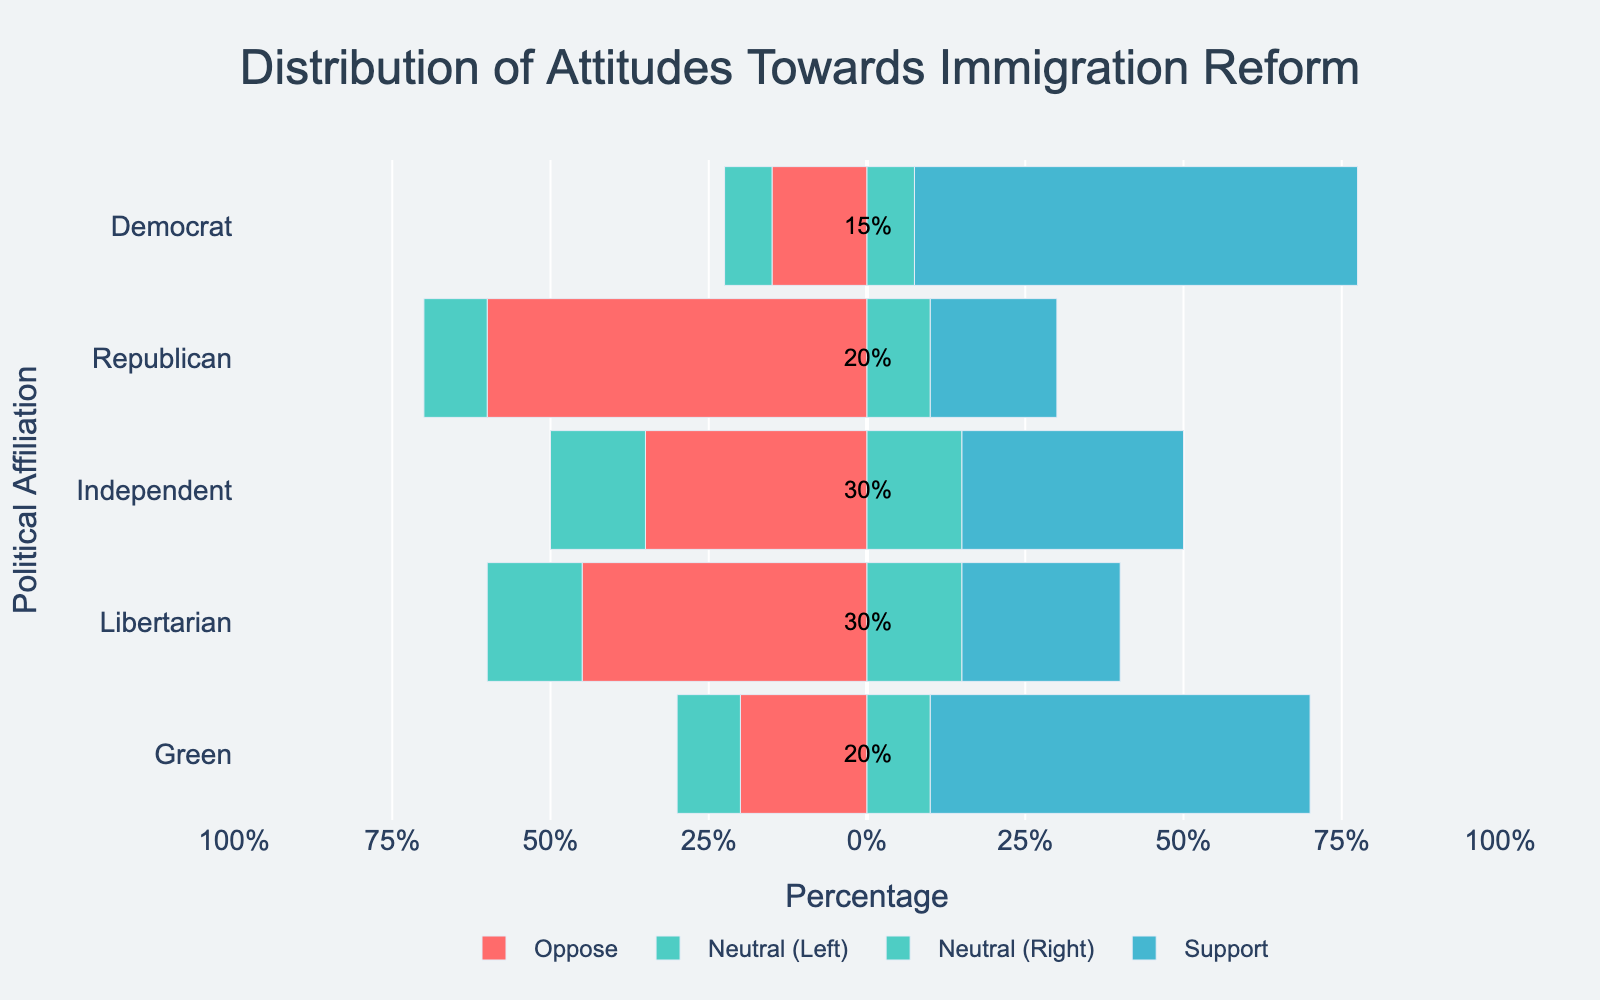what percentage of Democrats are neutral towards immigration reform? Democrats are represented by the bar for the "Democrat" category. The neutral segment is highlighted in green, with an annotation of 15%.
Answer: 15% which political affiliation has the highest percentage of strong support for immigration reform? By examining the bar segments coded in blue (strong support) for each political affiliation, the Democrat category has the highest percentage, indicated by the large blue section.
Answer: Democrats how does the opposition to immigration reform among Republicans compare to Libertarians? Both bars (Republican and Libertarian) have red sections for opposition (sum of strongly and somewhat oppose). The Republican bar is noticeably longer in total opposition, indicating higher opposition.
Answer: Republicans have higher opposition what is the total percentage of support among Independents? Independents' bar has two segments for support: somewhat (orange) and strongly (blue). Sum these segments: 20% (somewhat support) + 15% (strongly support) = 35%.
Answer: 35% what is the combined percentage of opposition and neutrality for Libertarians? For Libertarians, add the opposition (20% strongly + 25% somewhat = 45%) and neutrality (30%), resulting in a total: 45% + 30% = 75%.
Answer: 75% do Independents have more neutral respondents than Libertarians? Compare the green segments (neutral) for Independents and Libertarians. The Independent's neutral segment is 30%, while Libertarian's is also 30%.
Answer: They are the same which group has the smallest percentage of strong opposition to immigration reform? Examine the smallest red segments (strongly oppose) for each political affiliation. Democrats have the smallest percentage, indicated by the smallest red section (5%).
Answer: Democrats compare the percentage of strong support between Democrats and the Green party. The blue segments (strongly support) are compared for both parties. For Democrats, it is 45%, and for the Green party, it is 40%.
Answer: Democrats have a higher percentage among all affiliations, which one has an equal percentage of strong opposition and strong support? Scan the bars for equal lengths of the red and blue segments (same percentage). Libertarians show 20% in each segment for strong opposition and support.
Answer: Libertarians what is the median percentage of neutrality across all political affiliations? Sort neutrality percentages: 15% (Democrat), 20% (Republican), 30% (Independent, Libertarian), 20% (Green). The median value (middle value) is 20%.
Answer: 20% 